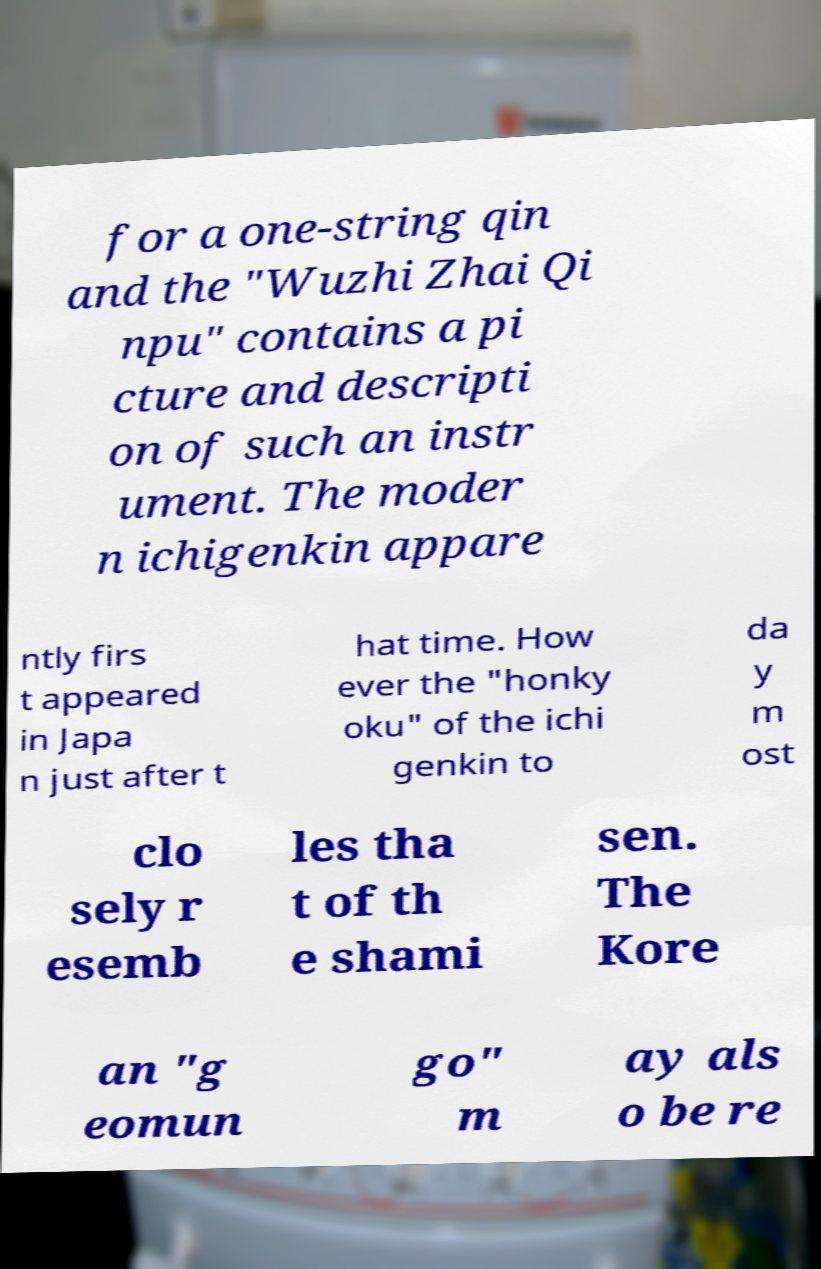Can you accurately transcribe the text from the provided image for me? for a one-string qin and the "Wuzhi Zhai Qi npu" contains a pi cture and descripti on of such an instr ument. The moder n ichigenkin appare ntly firs t appeared in Japa n just after t hat time. How ever the "honky oku" of the ichi genkin to da y m ost clo sely r esemb les tha t of th e shami sen. The Kore an "g eomun go" m ay als o be re 